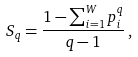Convert formula to latex. <formula><loc_0><loc_0><loc_500><loc_500>S _ { q } = \frac { 1 - \sum _ { i = 1 } ^ { W } p _ { i } ^ { q } } { q - 1 } \, ,</formula> 